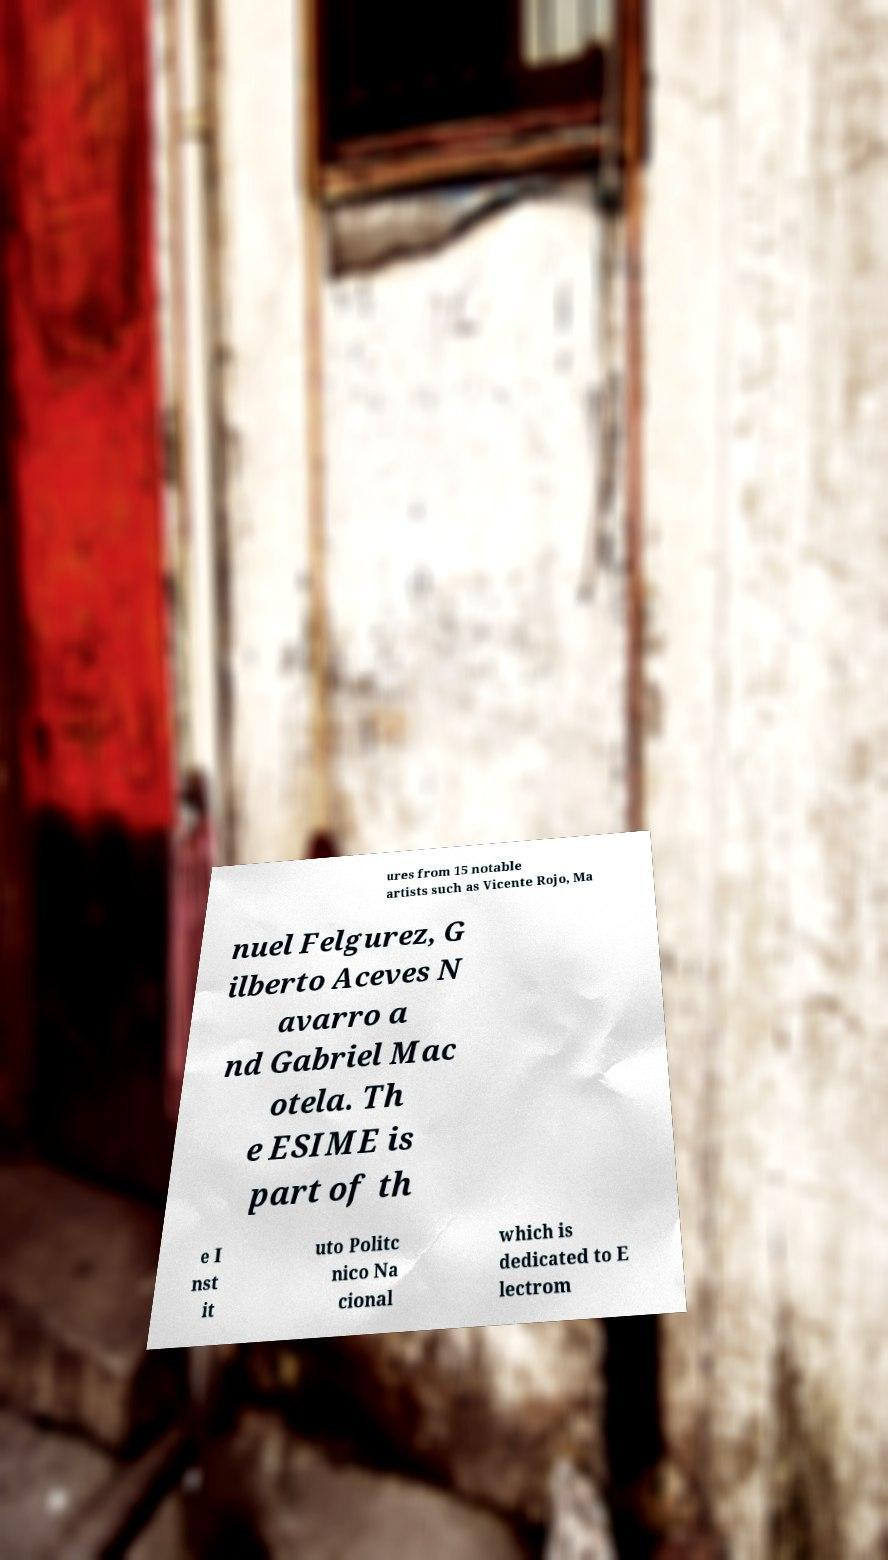Please identify and transcribe the text found in this image. ures from 15 notable artists such as Vicente Rojo, Ma nuel Felgurez, G ilberto Aceves N avarro a nd Gabriel Mac otela. Th e ESIME is part of th e I nst it uto Politc nico Na cional which is dedicated to E lectrom 